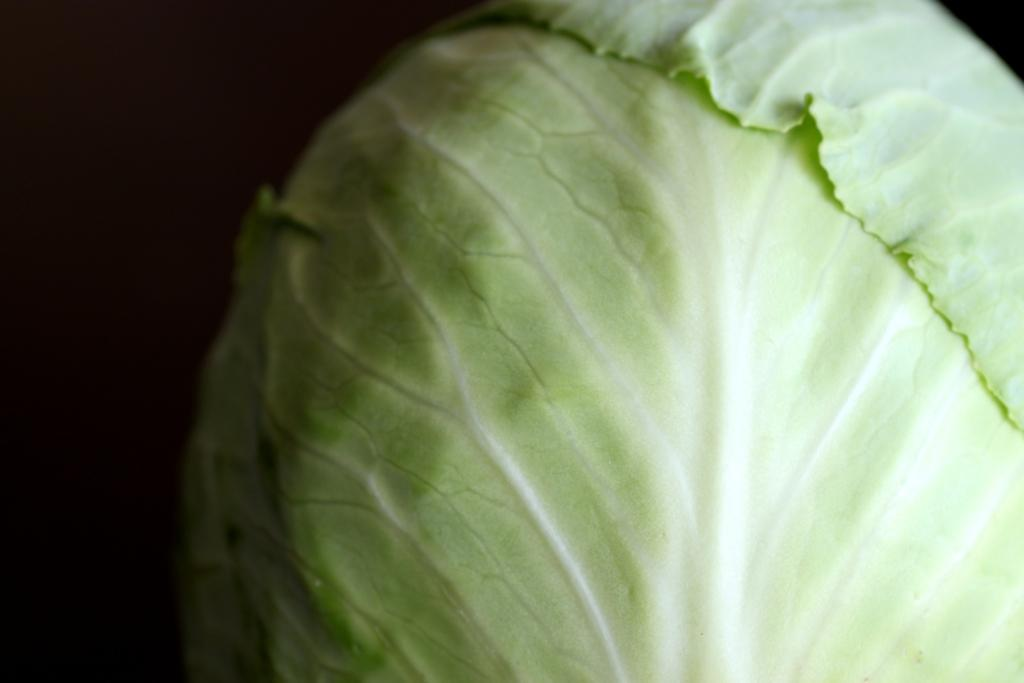What type of vegetable is present in the image? There is cabbage in the image. Can you describe the background of the image? The background of the image is dark. What type of mint can be seen growing in the image? There is no mint present in the image; it only features cabbage. What channel is the image from? The image is not from a channel, as it is a still image and not a video or broadcast. 